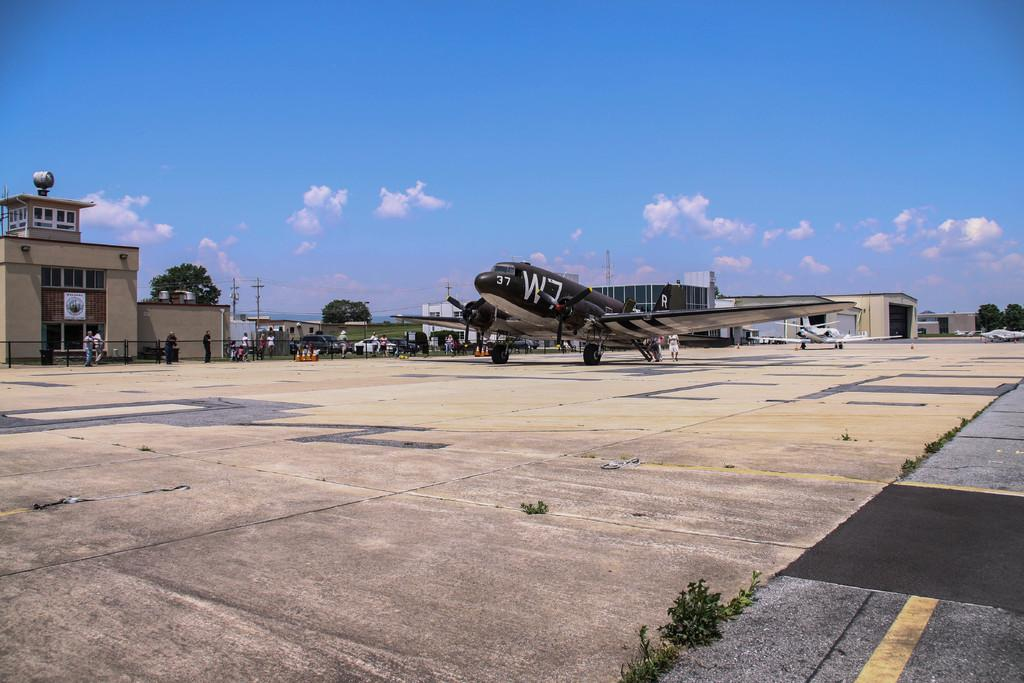<image>
Summarize the visual content of the image. The airfield has a black plane numbered 37 W7. 